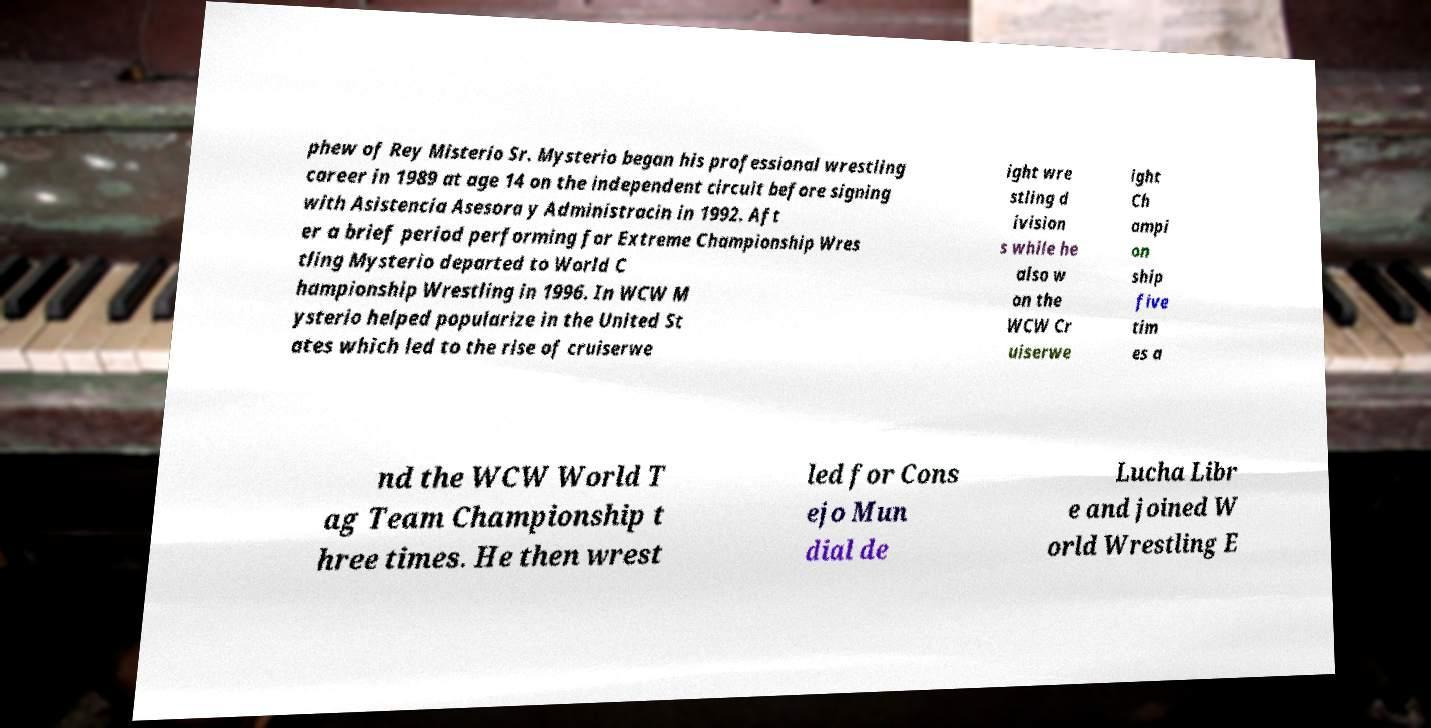Please read and relay the text visible in this image. What does it say? phew of Rey Misterio Sr. Mysterio began his professional wrestling career in 1989 at age 14 on the independent circuit before signing with Asistencia Asesora y Administracin in 1992. Aft er a brief period performing for Extreme Championship Wres tling Mysterio departed to World C hampionship Wrestling in 1996. In WCW M ysterio helped popularize in the United St ates which led to the rise of cruiserwe ight wre stling d ivision s while he also w on the WCW Cr uiserwe ight Ch ampi on ship five tim es a nd the WCW World T ag Team Championship t hree times. He then wrest led for Cons ejo Mun dial de Lucha Libr e and joined W orld Wrestling E 